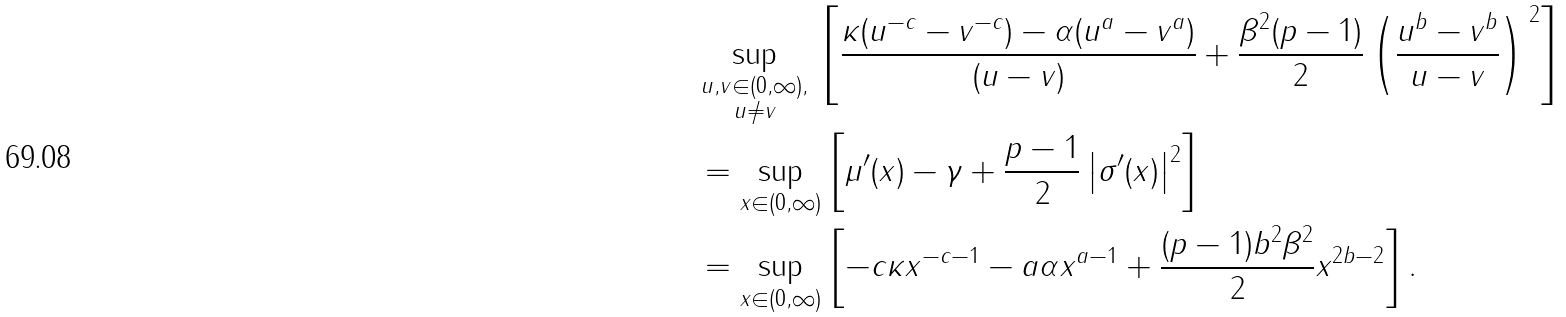<formula> <loc_0><loc_0><loc_500><loc_500>& \sup _ { \substack { u , v \in ( 0 , \infty ) , \\ u \neq v } } \, \left [ \frac { \kappa ( u ^ { - c } - v ^ { - c } ) - \alpha ( u ^ { a } - v ^ { a } ) } { ( u - v ) } + \frac { \beta ^ { 2 } ( p - 1 ) } { 2 } \left ( \frac { u ^ { b } - v ^ { b } } { u - v } \right ) ^ { \, 2 } \right ] \\ & = \sup _ { x \in ( 0 , \infty ) } \left [ \mu ^ { \prime } ( x ) - \gamma + \frac { p - 1 } { 2 } \left | \sigma ^ { \prime } ( x ) \right | ^ { 2 } \right ] \\ & = \sup _ { x \in ( 0 , \infty ) } \left [ - c \kappa x ^ { - c - 1 } - a \alpha x ^ { a - 1 } + \frac { ( p - 1 ) b ^ { 2 } \beta ^ { 2 } } { 2 } x ^ { 2 b - 2 } \right ] .</formula> 